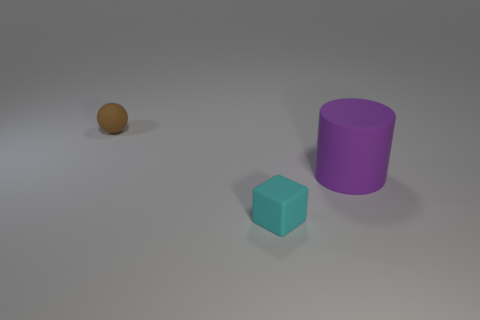Add 1 yellow matte cylinders. How many objects exist? 4 Subtract all cubes. How many objects are left? 2 Subtract 1 cylinders. How many cylinders are left? 0 Subtract all red balls. Subtract all gray cylinders. How many balls are left? 1 Subtract all large gray cylinders. Subtract all brown balls. How many objects are left? 2 Add 1 large rubber objects. How many large rubber objects are left? 2 Add 2 small red matte cylinders. How many small red matte cylinders exist? 2 Subtract 0 brown cylinders. How many objects are left? 3 